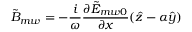Convert formula to latex. <formula><loc_0><loc_0><loc_500><loc_500>{ \tilde { B } _ { m w } } = - \frac { i } { \omega } \frac { \partial \tilde { E } _ { m w 0 } } { \partial x } ( \hat { z } - \alpha \hat { y } )</formula> 